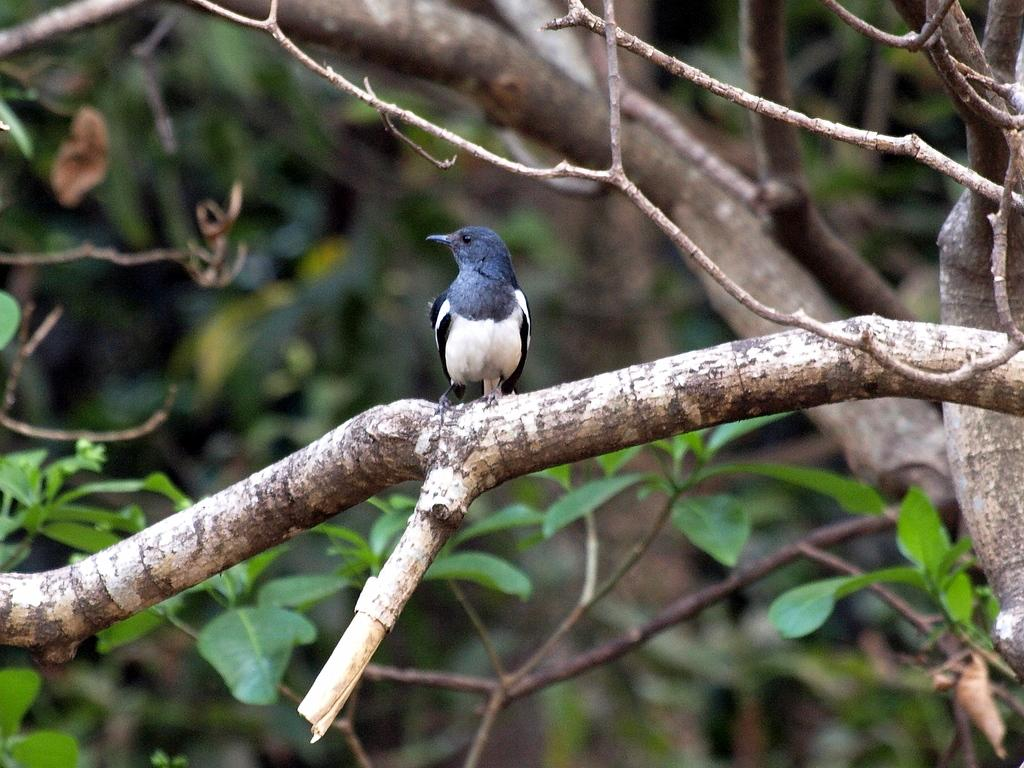What type of animal can be seen in the image? There is a bird in the image. Where is the bird located? The bird is on a tree branch. What can be seen in the background of the image? There are leaves visible in the background of the image. What type of body is the judge using to rub the bird in the image? There is no judge or rubbing action involving a bird in the image. The bird is simply perched on a tree branch. 